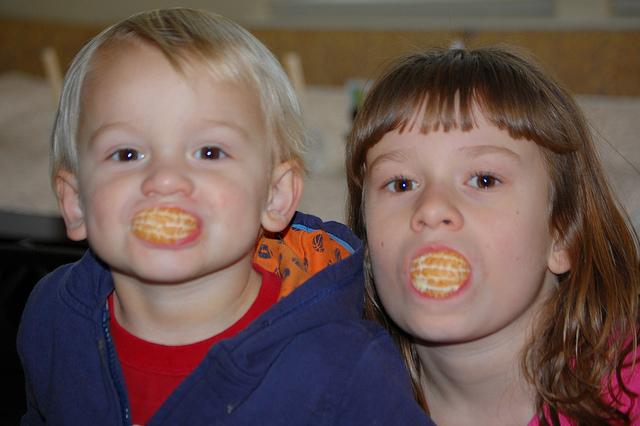What is in the children's mouths?
Quick response, please. Oranges. What is the kid holding that is orange?
Keep it brief. Orange. Which child is blonde?
Short answer required. Boy. Are both of these people the same age?
Concise answer only. No. Are those blinds behind the boy?
Short answer required. No. Are children on a bed?
Quick response, please. No. What part of the face are these orange slices meant to represent?
Give a very brief answer. Teeth. 